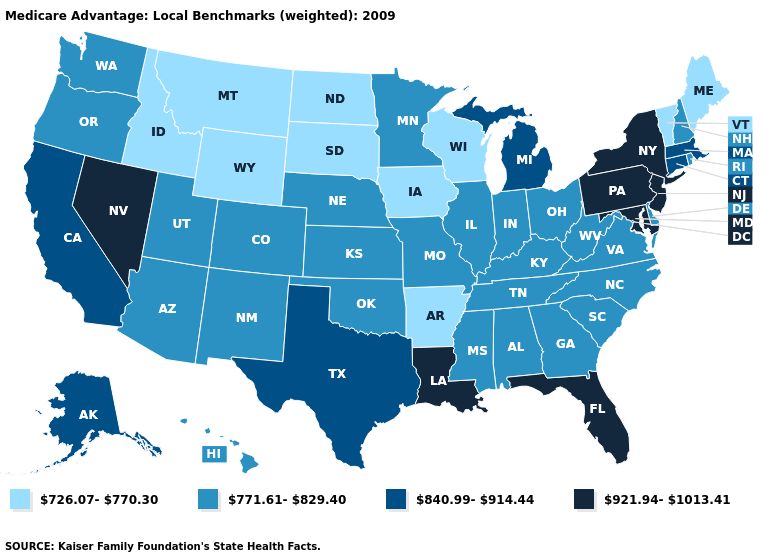Does the map have missing data?
Be succinct. No. Does Minnesota have the same value as Alaska?
Be succinct. No. Which states hav the highest value in the South?
Concise answer only. Florida, Louisiana, Maryland. Does Wisconsin have the lowest value in the MidWest?
Concise answer only. Yes. Which states have the lowest value in the USA?
Keep it brief. Arkansas, Iowa, Idaho, Maine, Montana, North Dakota, South Dakota, Vermont, Wisconsin, Wyoming. Does the map have missing data?
Quick response, please. No. Does the map have missing data?
Short answer required. No. Name the states that have a value in the range 840.99-914.44?
Concise answer only. Alaska, California, Connecticut, Massachusetts, Michigan, Texas. Which states hav the highest value in the Northeast?
Be succinct. New Jersey, New York, Pennsylvania. Name the states that have a value in the range 771.61-829.40?
Write a very short answer. Alabama, Arizona, Colorado, Delaware, Georgia, Hawaii, Illinois, Indiana, Kansas, Kentucky, Minnesota, Missouri, Mississippi, North Carolina, Nebraska, New Hampshire, New Mexico, Ohio, Oklahoma, Oregon, Rhode Island, South Carolina, Tennessee, Utah, Virginia, Washington, West Virginia. Name the states that have a value in the range 921.94-1013.41?
Concise answer only. Florida, Louisiana, Maryland, New Jersey, Nevada, New York, Pennsylvania. Does Alabama have the highest value in the USA?
Keep it brief. No. What is the value of Massachusetts?
Write a very short answer. 840.99-914.44. Does Rhode Island have the same value as Oklahoma?
Write a very short answer. Yes. What is the value of Rhode Island?
Quick response, please. 771.61-829.40. 